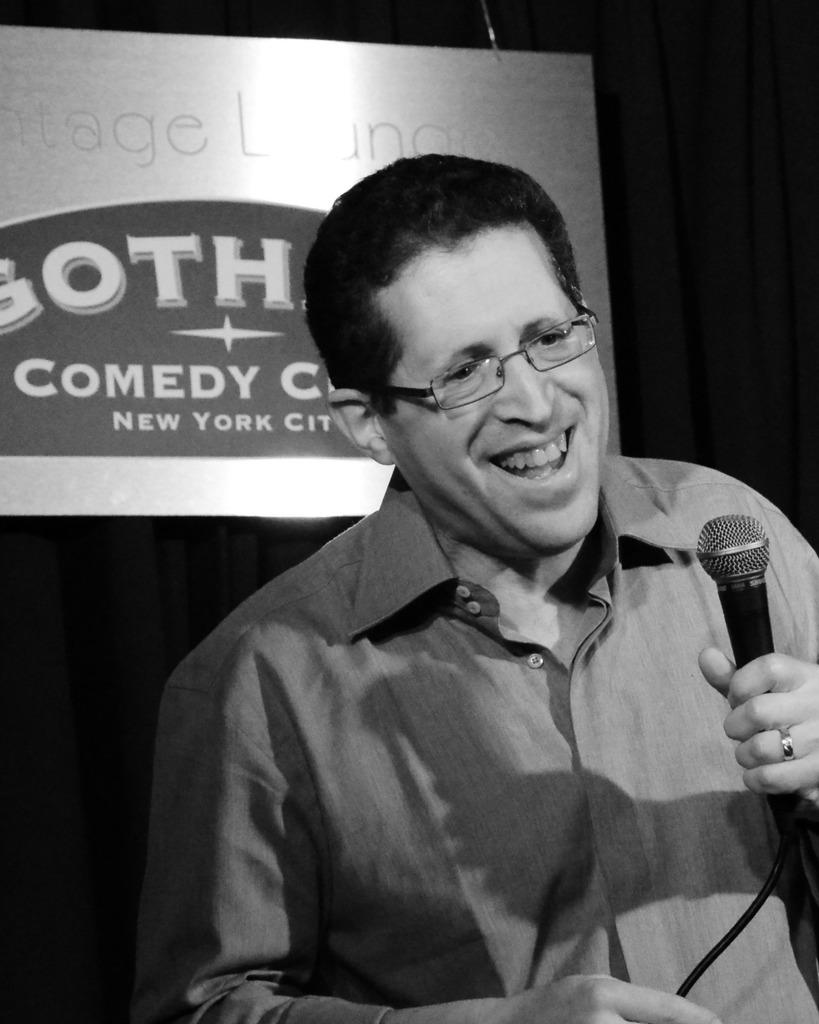What is the man in the image doing? The man is holding a mic in his hand. What is the man's facial expression in the image? The man is smiling. What can be seen in the background of the image? There is a poster in the background of the image. What type of lizards can be seen crawling on the man's shoulder in the image? There are no lizards present in the image; the man is holding a mic and smiling. 